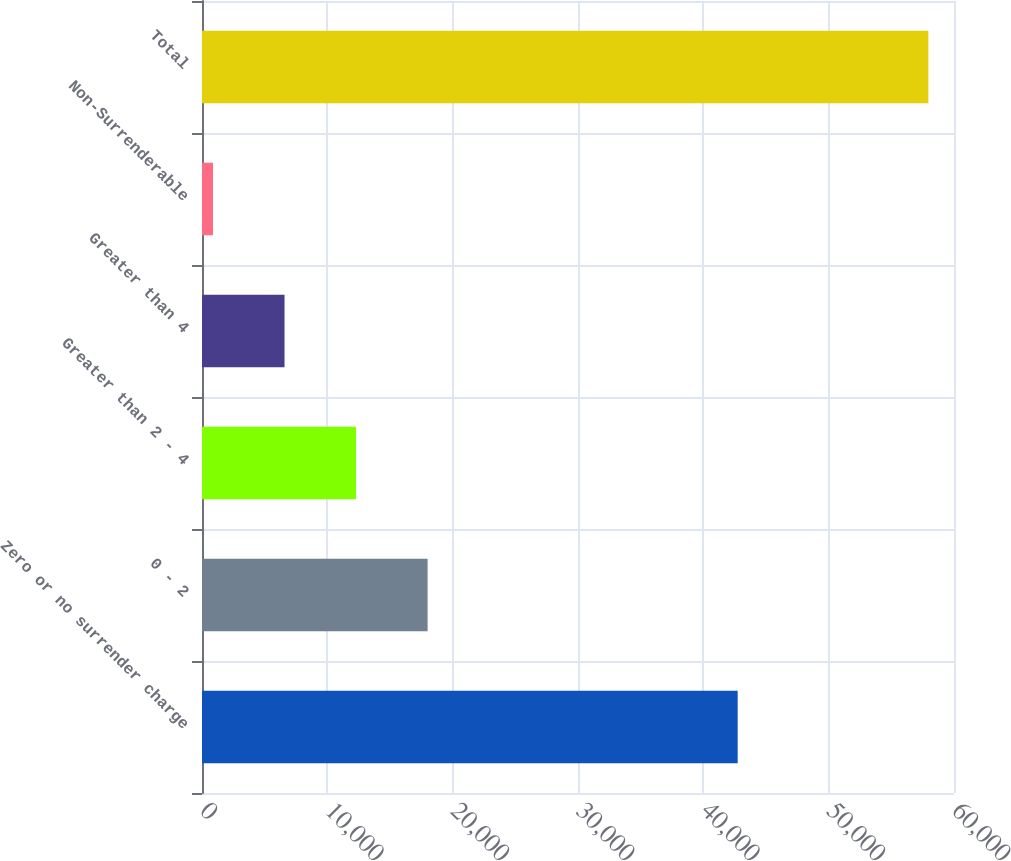Convert chart to OTSL. <chart><loc_0><loc_0><loc_500><loc_500><bar_chart><fcel>Zero or no surrender charge<fcel>0 - 2<fcel>Greater than 2 - 4<fcel>Greater than 4<fcel>Non-Surrenderable<fcel>Total<nl><fcel>42741<fcel>18000.1<fcel>12292.4<fcel>6584.7<fcel>877<fcel>57954<nl></chart> 